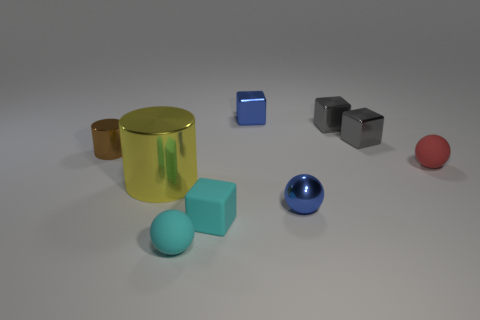Is the large thing the same shape as the small brown metal object?
Keep it short and to the point. Yes. What is the color of the matte sphere that is right of the small rubber ball that is in front of the large metallic thing?
Offer a very short reply. Red. What number of other objects are the same material as the yellow thing?
Make the answer very short. 5. Are there the same number of red things that are in front of the tiny red matte object and large metal spheres?
Offer a very short reply. Yes. What material is the yellow object that is on the left side of the tiny blue metal object that is in front of the small blue object that is behind the big yellow metallic thing?
Your answer should be compact. Metal. There is a metallic cylinder that is in front of the small brown metal object; what is its color?
Provide a succinct answer. Yellow. What size is the yellow object behind the tiny blue thing in front of the brown cylinder?
Ensure brevity in your answer.  Large. Are there the same number of gray shiny objects left of the blue cube and tiny red objects to the left of the tiny rubber block?
Your answer should be very brief. Yes. Is there anything else that is the same size as the yellow thing?
Your answer should be compact. No. There is a small sphere that is made of the same material as the blue cube; what is its color?
Offer a terse response. Blue. 